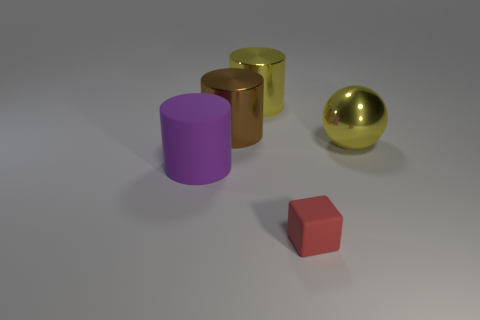Subtract all big yellow cylinders. How many cylinders are left? 2 Subtract all brown cylinders. How many cylinders are left? 2 Add 1 large purple objects. How many objects exist? 6 Subtract all spheres. How many objects are left? 4 Subtract all big yellow shiny spheres. Subtract all red matte things. How many objects are left? 3 Add 3 yellow metallic spheres. How many yellow metallic spheres are left? 4 Add 1 big yellow metal cylinders. How many big yellow metal cylinders exist? 2 Subtract 0 green cubes. How many objects are left? 5 Subtract all blue cylinders. Subtract all blue spheres. How many cylinders are left? 3 